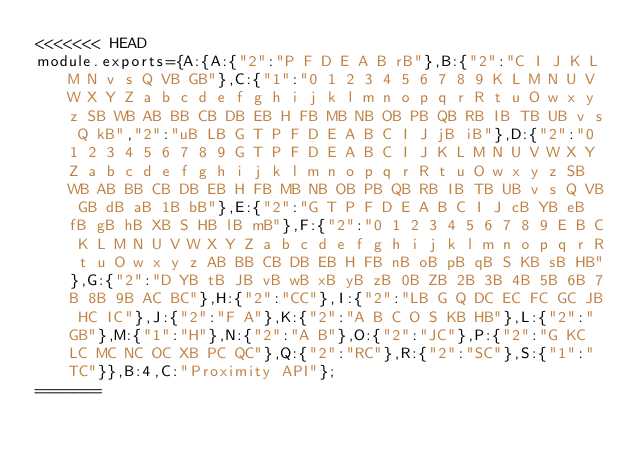Convert code to text. <code><loc_0><loc_0><loc_500><loc_500><_JavaScript_><<<<<<< HEAD
module.exports={A:{A:{"2":"P F D E A B rB"},B:{"2":"C I J K L M N v s Q VB GB"},C:{"1":"0 1 2 3 4 5 6 7 8 9 K L M N U V W X Y Z a b c d e f g h i j k l m n o p q r R t u O w x y z SB WB AB BB CB DB EB H FB MB NB OB PB QB RB IB TB UB v s Q kB","2":"uB LB G T P F D E A B C I J jB iB"},D:{"2":"0 1 2 3 4 5 6 7 8 9 G T P F D E A B C I J K L M N U V W X Y Z a b c d e f g h i j k l m n o p q r R t u O w x y z SB WB AB BB CB DB EB H FB MB NB OB PB QB RB IB TB UB v s Q VB GB dB aB 1B bB"},E:{"2":"G T P F D E A B C I J cB YB eB fB gB hB XB S HB lB mB"},F:{"2":"0 1 2 3 4 5 6 7 8 9 E B C K L M N U V W X Y Z a b c d e f g h i j k l m n o p q r R t u O w x y z AB BB CB DB EB H FB nB oB pB qB S KB sB HB"},G:{"2":"D YB tB JB vB wB xB yB zB 0B ZB 2B 3B 4B 5B 6B 7B 8B 9B AC BC"},H:{"2":"CC"},I:{"2":"LB G Q DC EC FC GC JB HC IC"},J:{"2":"F A"},K:{"2":"A B C O S KB HB"},L:{"2":"GB"},M:{"1":"H"},N:{"2":"A B"},O:{"2":"JC"},P:{"2":"G KC LC MC NC OC XB PC QC"},Q:{"2":"RC"},R:{"2":"SC"},S:{"1":"TC"}},B:4,C:"Proximity API"};
=======</code> 